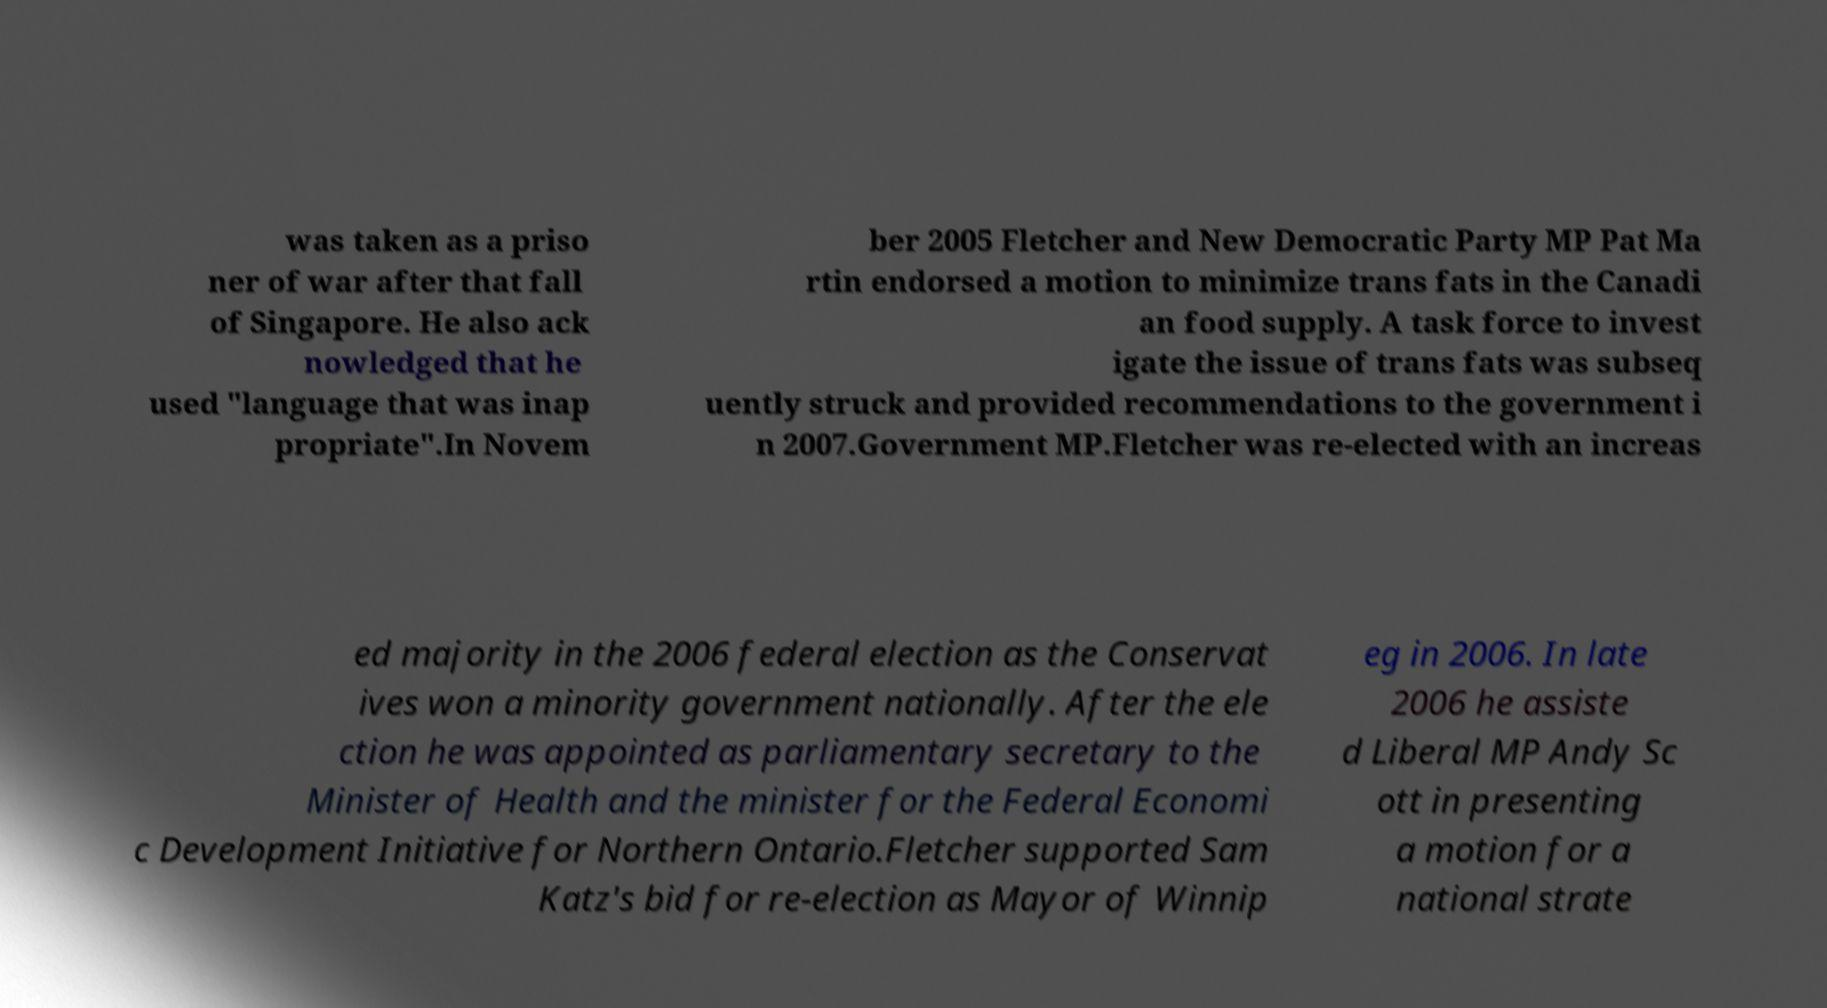Please identify and transcribe the text found in this image. was taken as a priso ner of war after that fall of Singapore. He also ack nowledged that he used "language that was inap propriate".In Novem ber 2005 Fletcher and New Democratic Party MP Pat Ma rtin endorsed a motion to minimize trans fats in the Canadi an food supply. A task force to invest igate the issue of trans fats was subseq uently struck and provided recommendations to the government i n 2007.Government MP.Fletcher was re-elected with an increas ed majority in the 2006 federal election as the Conservat ives won a minority government nationally. After the ele ction he was appointed as parliamentary secretary to the Minister of Health and the minister for the Federal Economi c Development Initiative for Northern Ontario.Fletcher supported Sam Katz's bid for re-election as Mayor of Winnip eg in 2006. In late 2006 he assiste d Liberal MP Andy Sc ott in presenting a motion for a national strate 